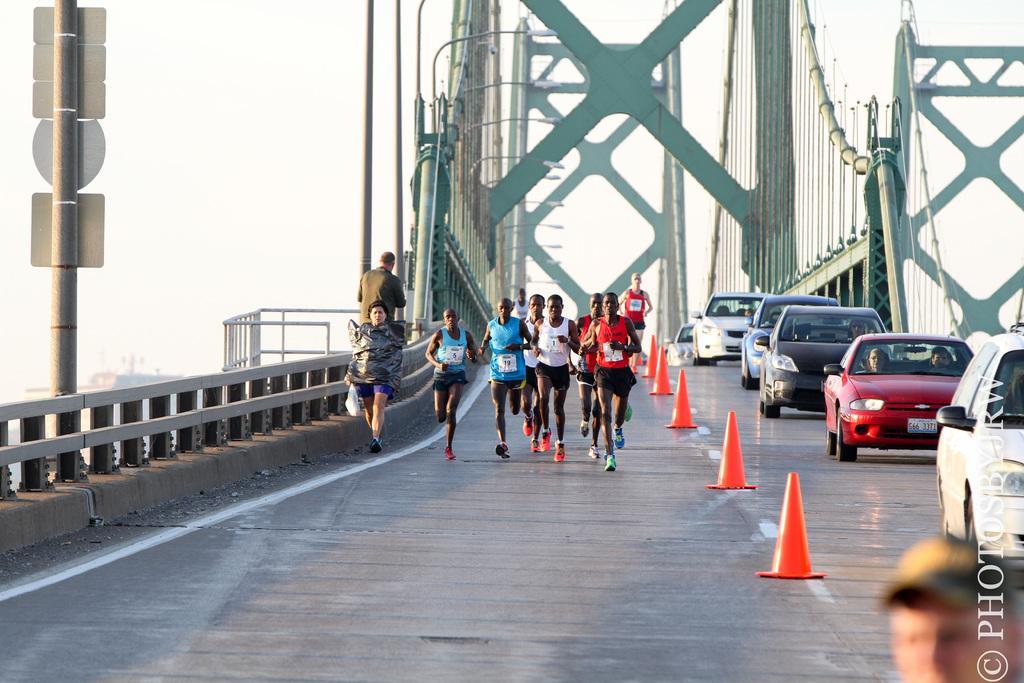Could you give a brief overview of what you see in this image? There are group of people running and two persons are walking. These are the cars moving on the road. These are the streetlights. This looks like like a bridge which is built with iron. This is a pole with some boards attached to the pole. These are used like a divider on the roads,which are orange in color. 